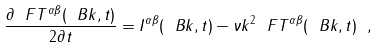Convert formula to latex. <formula><loc_0><loc_0><loc_500><loc_500>\frac { \partial \ F T ^ { \alpha \beta } ( \ B k , t ) } { 2 \partial t } = I ^ { \alpha \beta } ( \ B k , t ) - \nu k ^ { 2 } \ F T ^ { \alpha \beta } ( \ B k , t ) \ ,</formula> 